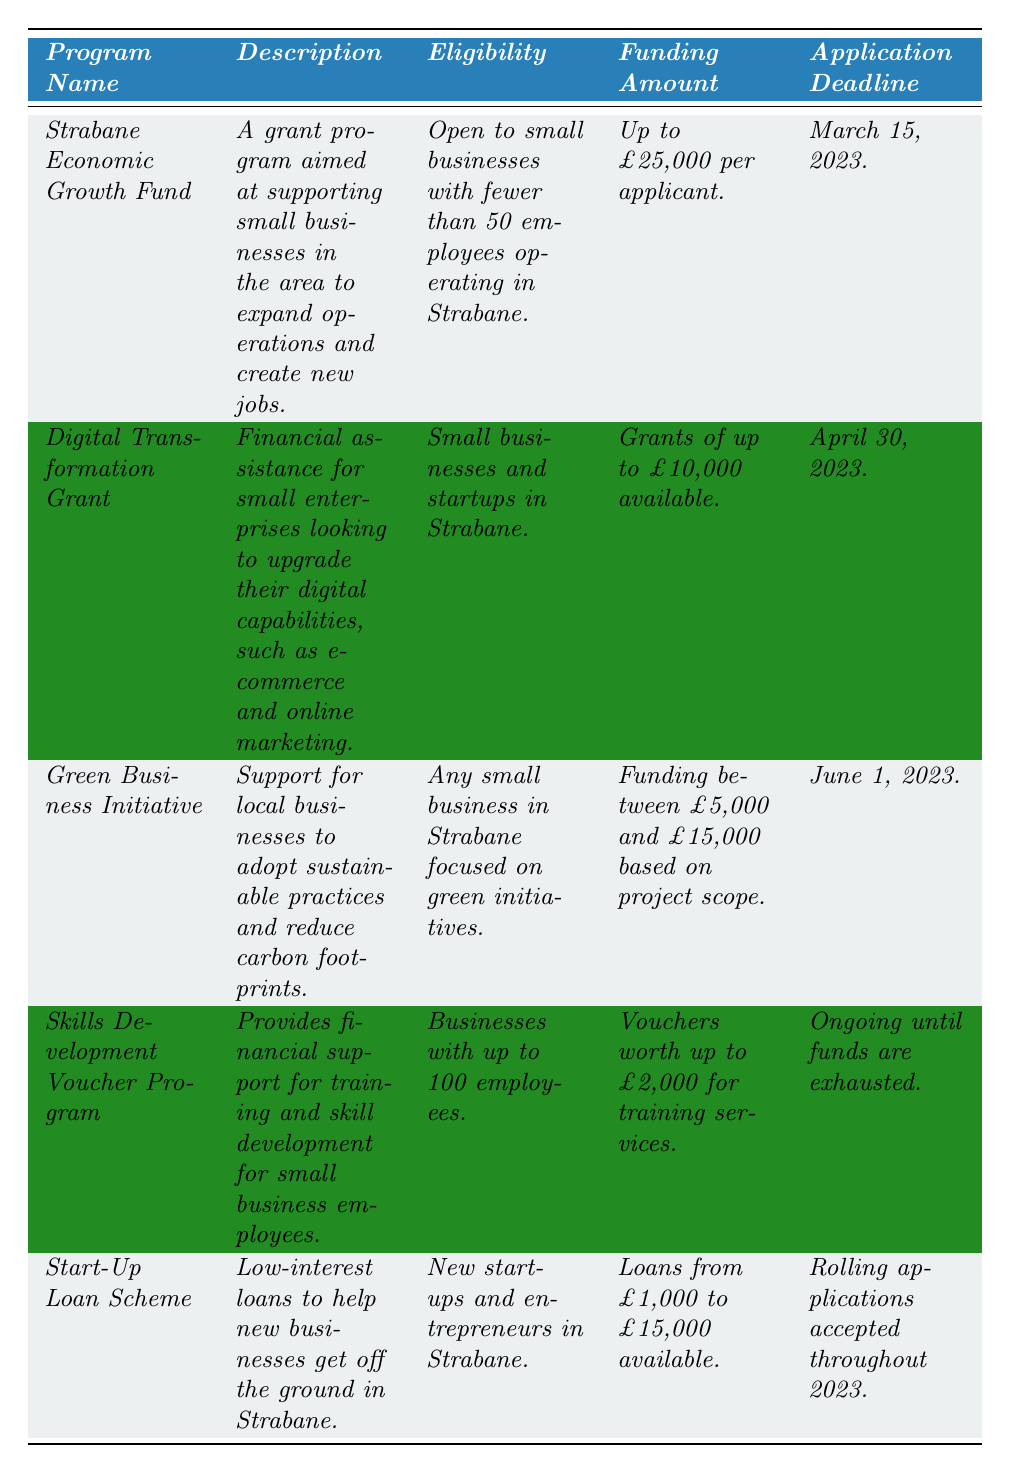What type of funding is available for the Strabane Economic Growth Fund? The table specifies that the Strabane Economic Growth Fund offers funding of up to £25,000 per applicant.
Answer: Up to £25,000 Which program requires applications to be submitted by April 30, 2023? According to the application deadlines listed in the table, the Digital Transformation Grant has the deadline of April 30, 2023.
Answer: Digital Transformation Grant Is the Green Business Initiative open to all small businesses in Strabane? The eligibility criteria for the Green Business Initiative specify that it is open to any small business in Strabane focused on green initiatives, confirming it is not universally open to all.
Answer: Yes How much funding can a business receive through the Skills Development Voucher Program? As per the table, the Skills Development Voucher Program provides vouchers worth up to £2,000 for training services.
Answer: Up to £2,000 Which program has the latest application deadline? The deadlines listed show that the Skills Development Voucher Program is ongoing until funds are exhausted, while the latest specific deadline is for the Green Business Initiative on June 1, 2023, meaning the programs do not have a strict end date for applications.
Answer: Skills Development Voucher Program What is the funding range for the Green Business Initiative? The Green Business Initiative offers funding between £5,000 and £15,000 based on the project scope, as stated in the table.
Answer: £5,000 to £15,000 Which two programs are specifically designed for new businesses? The Start-Up Loan Scheme aims at new startups and entrepreneurs, while the Digital Transformation Grant is also available for small enterprises, which may include startups, making both applicable.
Answer: Start-Up Loan Scheme and Digital Transformation Grant If a business wanted to apply for funding in March, which program would they choose? The table indicates that the Strabane Economic Growth Fund has an application deadline of March 15, 2023, making it the only option for March applications.
Answer: Strabane Economic Growth Fund How many programs offer substantial funding above £10,000? The Strabane Economic Growth Fund offers up to £25,000, the Green Business Initiative offers between £5,000 and £15,000, and the Start-Up Loan Scheme offers loans up to £15,000, totaling three programs that meet this criterion.
Answer: Three programs Is there a program that supports training for business employees? The Skills Development Voucher Program is specifically designed to provide financial support for training and skill development for employees of small businesses.
Answer: Yes 